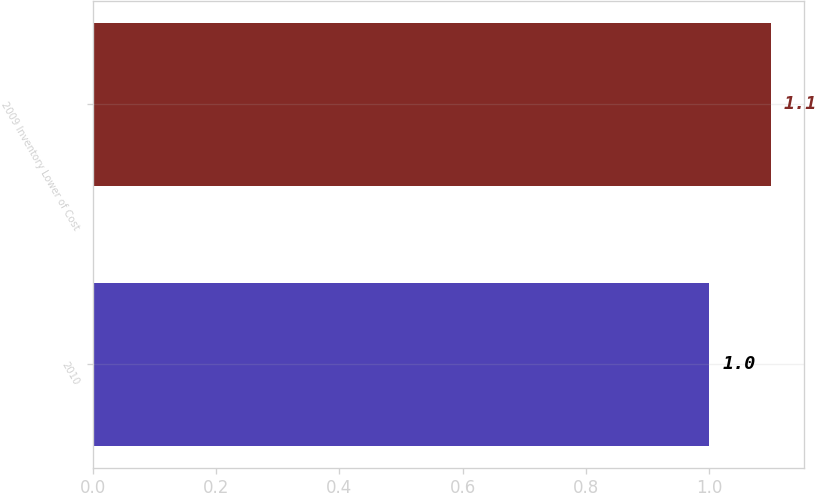<chart> <loc_0><loc_0><loc_500><loc_500><bar_chart><fcel>2010<fcel>2009 Inventory Lower of Cost<nl><fcel>1<fcel>1.1<nl></chart> 